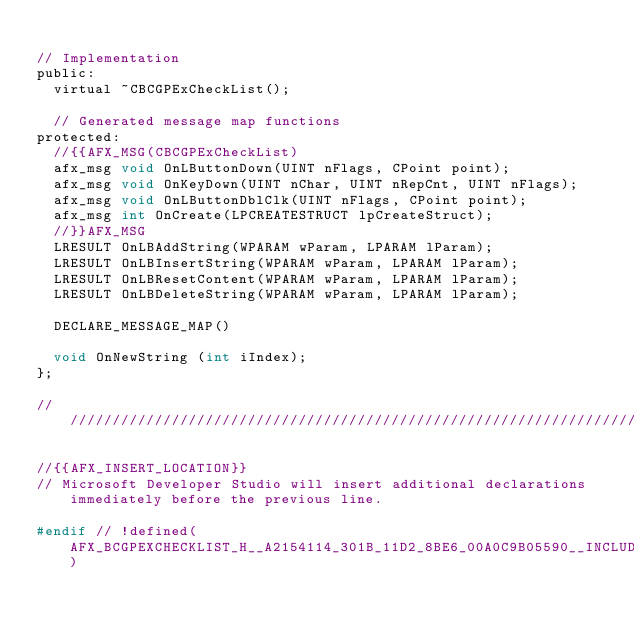<code> <loc_0><loc_0><loc_500><loc_500><_C_>
// Implementation
public:
	virtual ~CBCGPExCheckList();

	// Generated message map functions
protected:
	//{{AFX_MSG(CBCGPExCheckList)
	afx_msg void OnLButtonDown(UINT nFlags, CPoint point);
	afx_msg void OnKeyDown(UINT nChar, UINT nRepCnt, UINT nFlags);
	afx_msg void OnLButtonDblClk(UINT nFlags, CPoint point);
	afx_msg int OnCreate(LPCREATESTRUCT lpCreateStruct);
	//}}AFX_MSG
	LRESULT OnLBAddString(WPARAM wParam, LPARAM lParam);
	LRESULT OnLBInsertString(WPARAM wParam, LPARAM lParam);
	LRESULT OnLBResetContent(WPARAM wParam, LPARAM lParam);
	LRESULT OnLBDeleteString(WPARAM wParam, LPARAM lParam);

	DECLARE_MESSAGE_MAP()

	void OnNewString (int iIndex);
};

/////////////////////////////////////////////////////////////////////////////

//{{AFX_INSERT_LOCATION}}
// Microsoft Developer Studio will insert additional declarations immediately before the previous line.

#endif // !defined(AFX_BCGPEXCHECKLIST_H__A2154114_301B_11D2_8BE6_00A0C9B05590__INCLUDED_)
</code> 